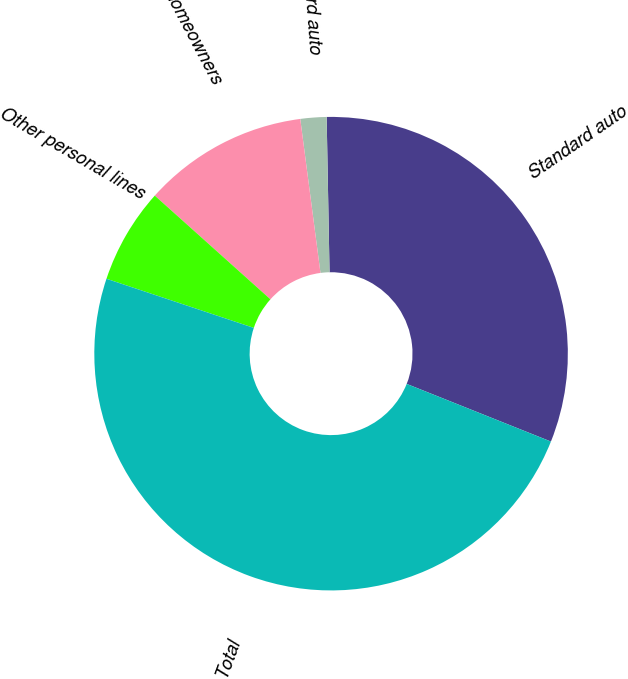Convert chart to OTSL. <chart><loc_0><loc_0><loc_500><loc_500><pie_chart><fcel>Standard auto<fcel>Non-standard auto<fcel>Homeowners<fcel>Other personal lines<fcel>Total<nl><fcel>31.35%<fcel>1.78%<fcel>11.29%<fcel>6.51%<fcel>49.07%<nl></chart> 